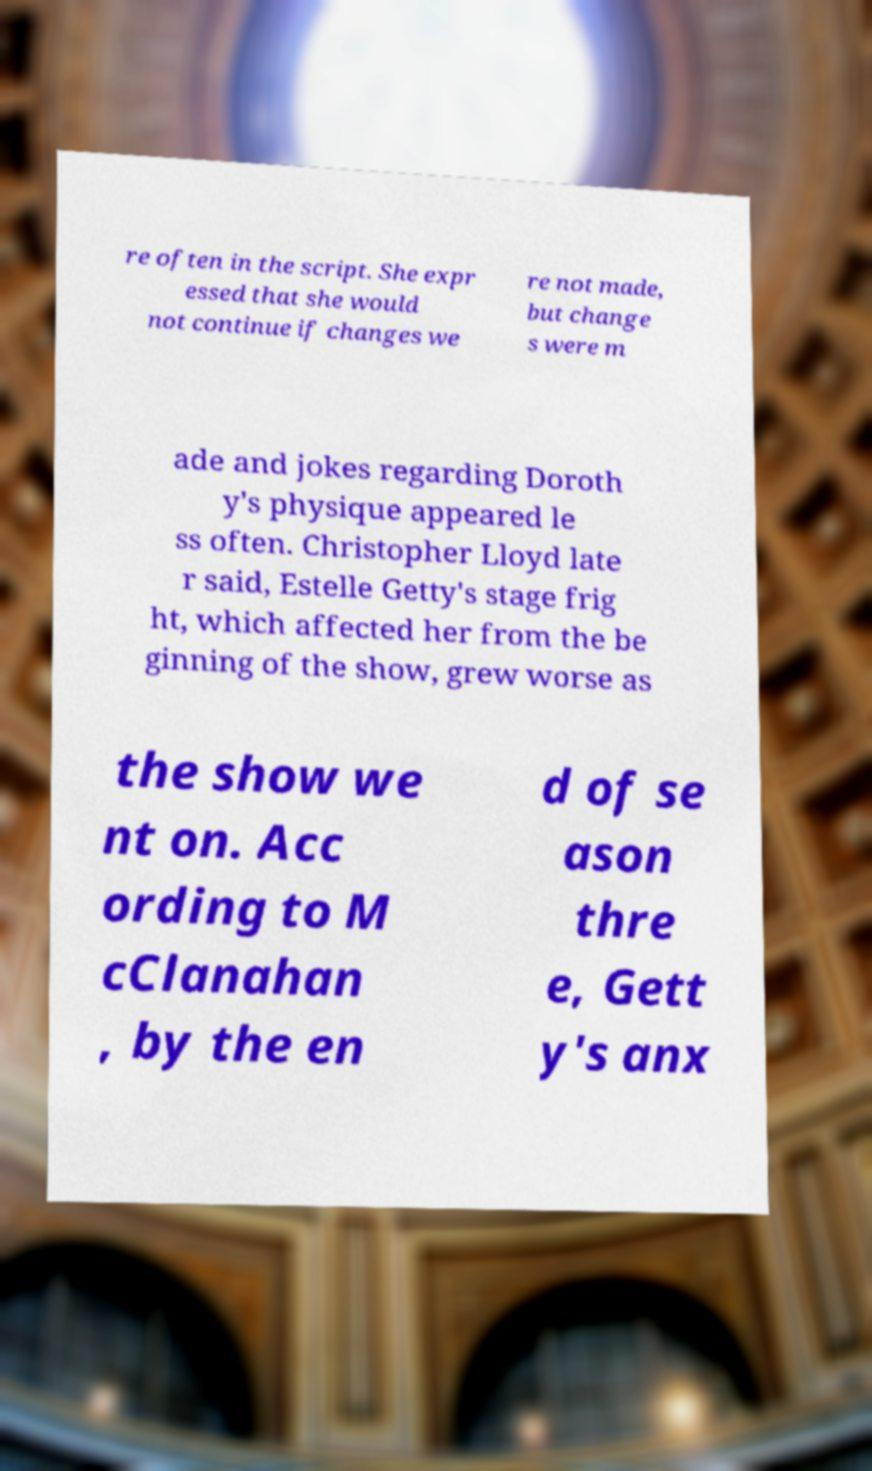Please read and relay the text visible in this image. What does it say? re often in the script. She expr essed that she would not continue if changes we re not made, but change s were m ade and jokes regarding Doroth y's physique appeared le ss often. Christopher Lloyd late r said, Estelle Getty's stage frig ht, which affected her from the be ginning of the show, grew worse as the show we nt on. Acc ording to M cClanahan , by the en d of se ason thre e, Gett y's anx 